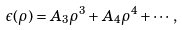<formula> <loc_0><loc_0><loc_500><loc_500>\epsilon ( \rho ) = A _ { 3 } \rho ^ { 3 } + A _ { 4 } \rho ^ { 4 } + \cdots ,</formula> 